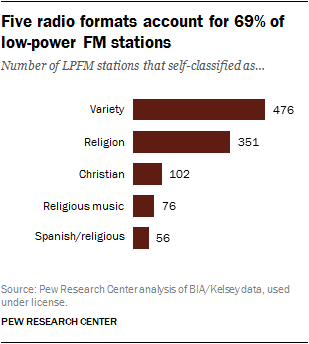Outline some significant characteristics in this image. The most popular format in the chart is variety. The chart shows a total of 585 religious stations. 